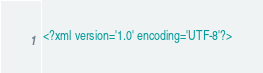<code> <loc_0><loc_0><loc_500><loc_500><_XML_><?xml version='1.0' encoding='UTF-8'?></code> 